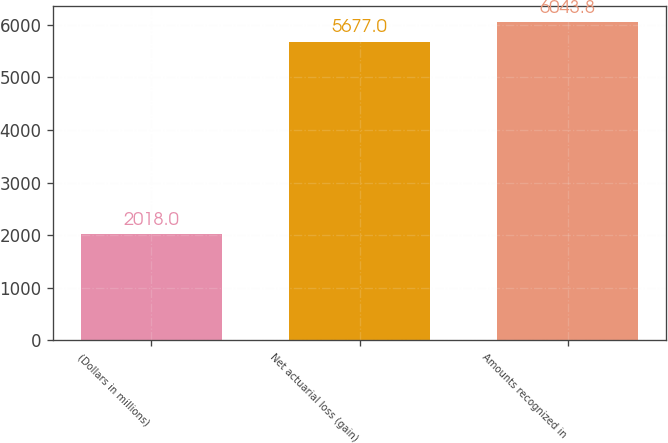<chart> <loc_0><loc_0><loc_500><loc_500><bar_chart><fcel>(Dollars in millions)<fcel>Net actuarial loss (gain)<fcel>Amounts recognized in<nl><fcel>2018<fcel>5677<fcel>6043.8<nl></chart> 